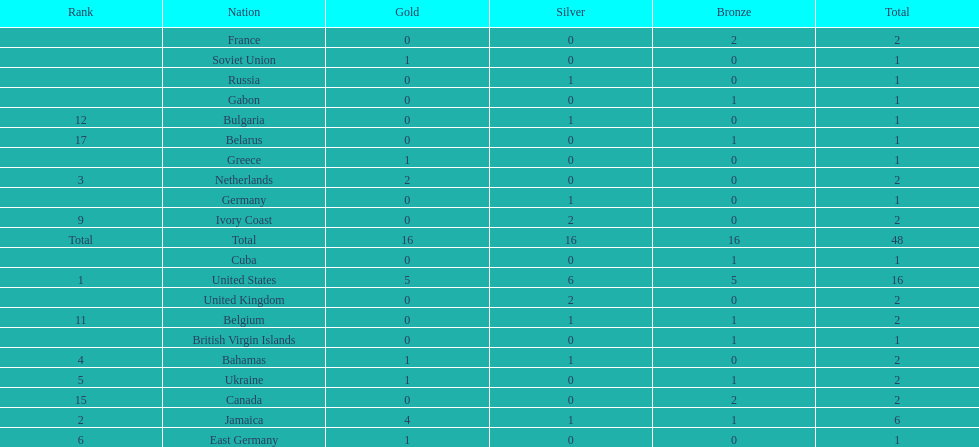How many nations received more medals than canada? 2. 